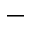Convert formula to latex. <formula><loc_0><loc_0><loc_500><loc_500>-</formula> 